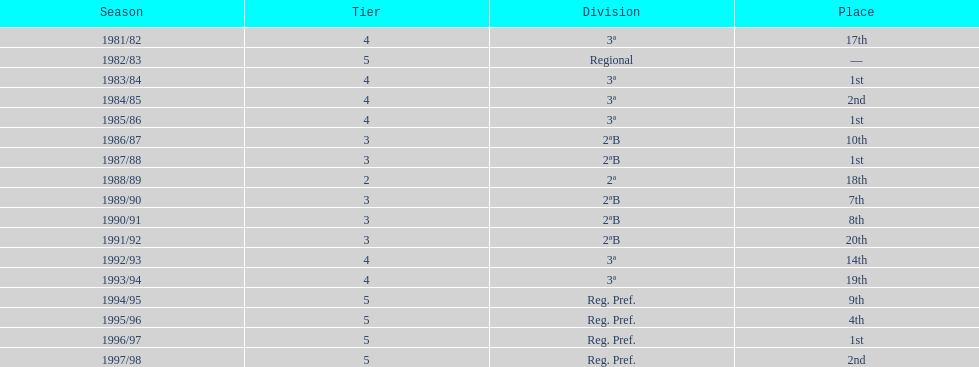How many times was the runner-up position achieved? 2. 